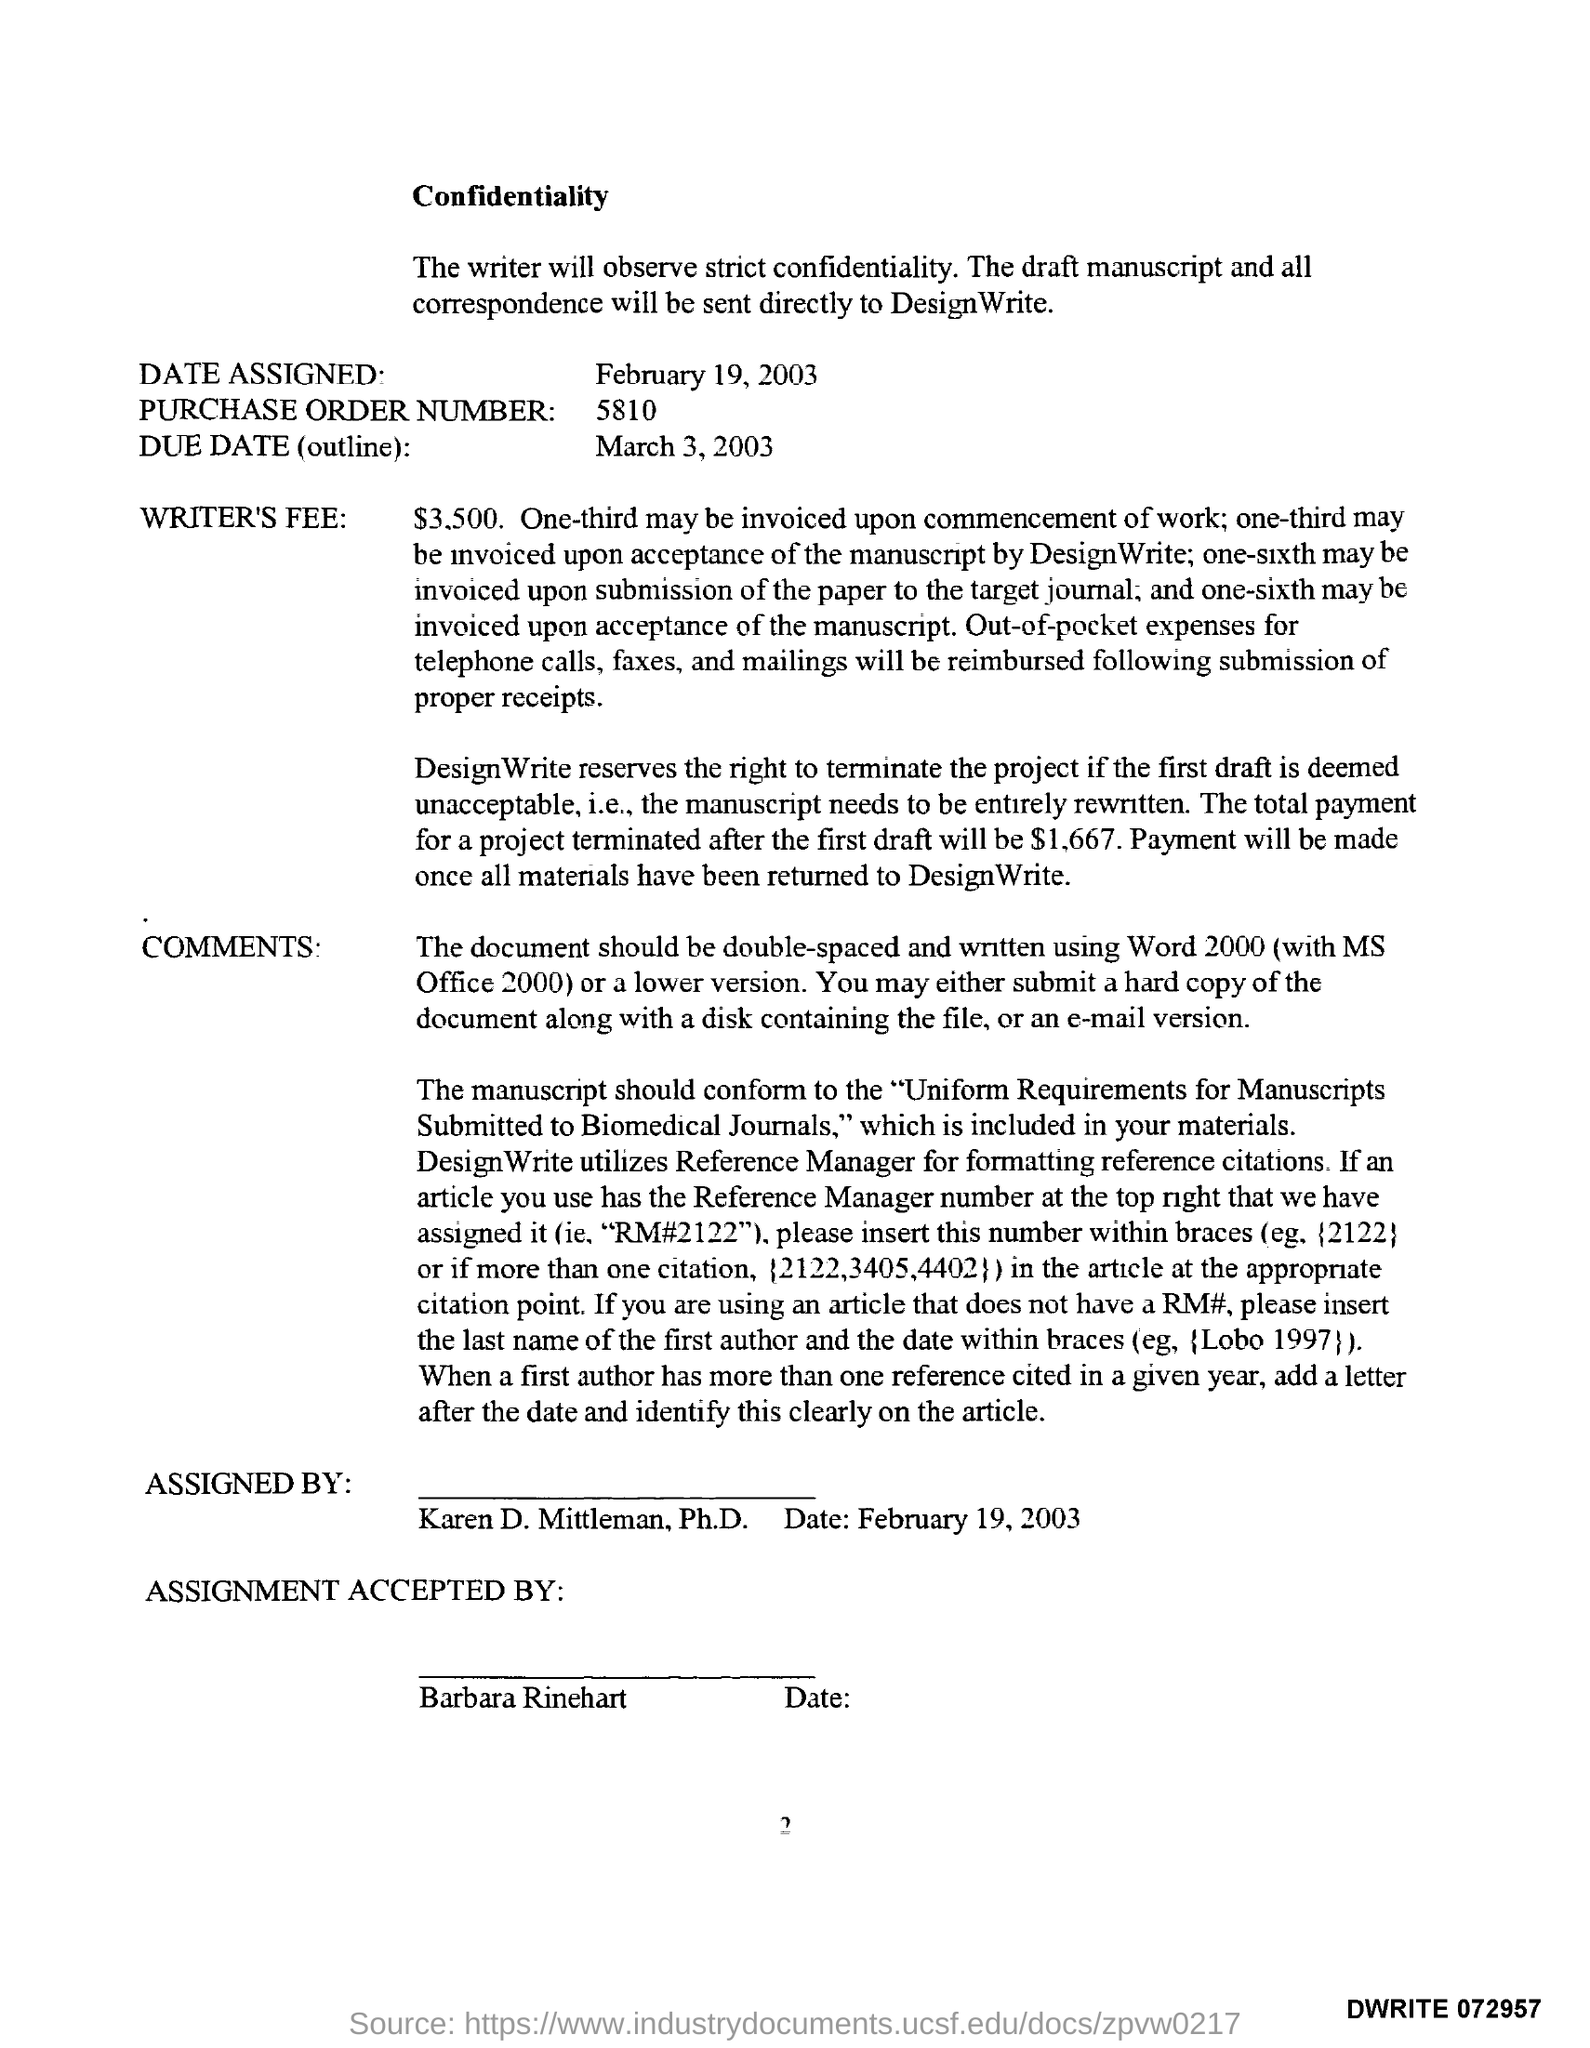Indicate a few pertinent items in this graphic. What is the purchase order number?" is a question. "5810" is a numerical value. The due date is March 3, 2003. The total payment for a project that is terminated after the first draft is $1,667. The acceptance of an assignment is done by Barbara Rinehart. Karen D. Mittleman has assigned this. 